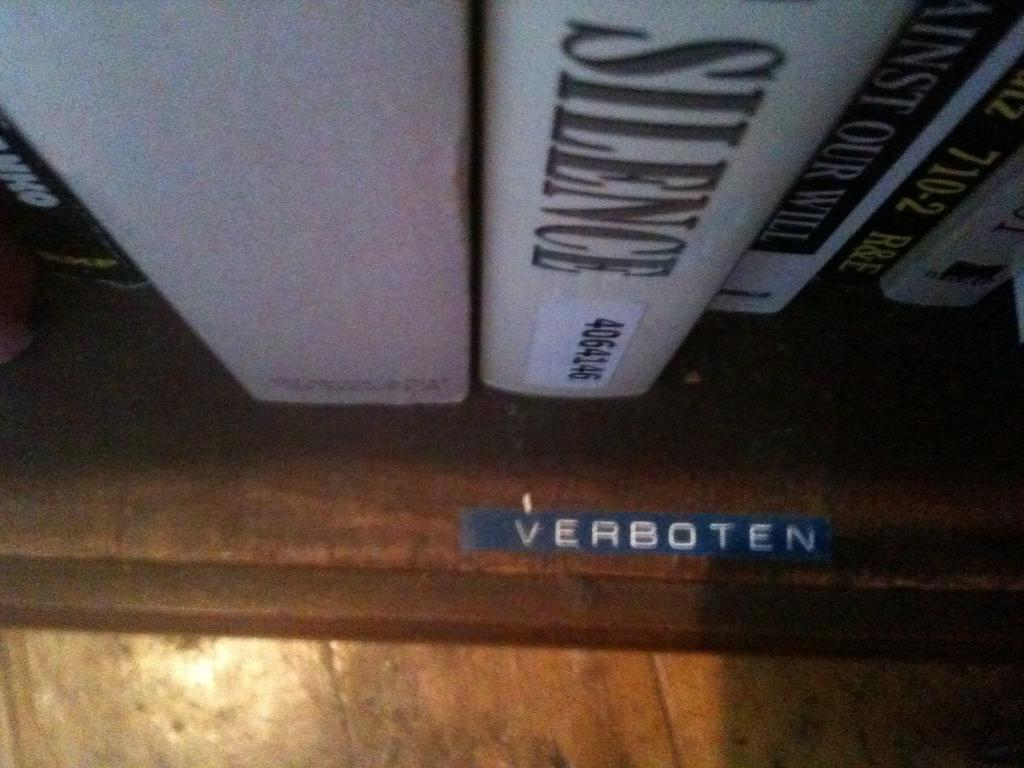<image>
Offer a succinct explanation of the picture presented. A book called SILENCE sits on a shelf labeled VERBOTEN. 